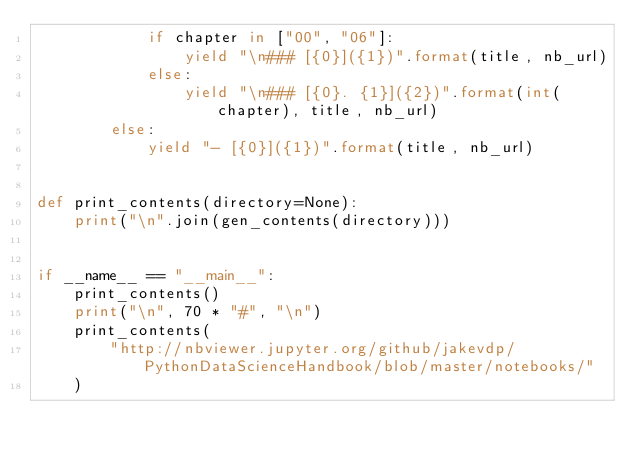<code> <loc_0><loc_0><loc_500><loc_500><_Python_>            if chapter in ["00", "06"]:
                yield "\n### [{0}]({1})".format(title, nb_url)
            else:
                yield "\n### [{0}. {1}]({2})".format(int(chapter), title, nb_url)
        else:
            yield "- [{0}]({1})".format(title, nb_url)


def print_contents(directory=None):
    print("\n".join(gen_contents(directory)))


if __name__ == "__main__":
    print_contents()
    print("\n", 70 * "#", "\n")
    print_contents(
        "http://nbviewer.jupyter.org/github/jakevdp/PythonDataScienceHandbook/blob/master/notebooks/"
    )
</code> 